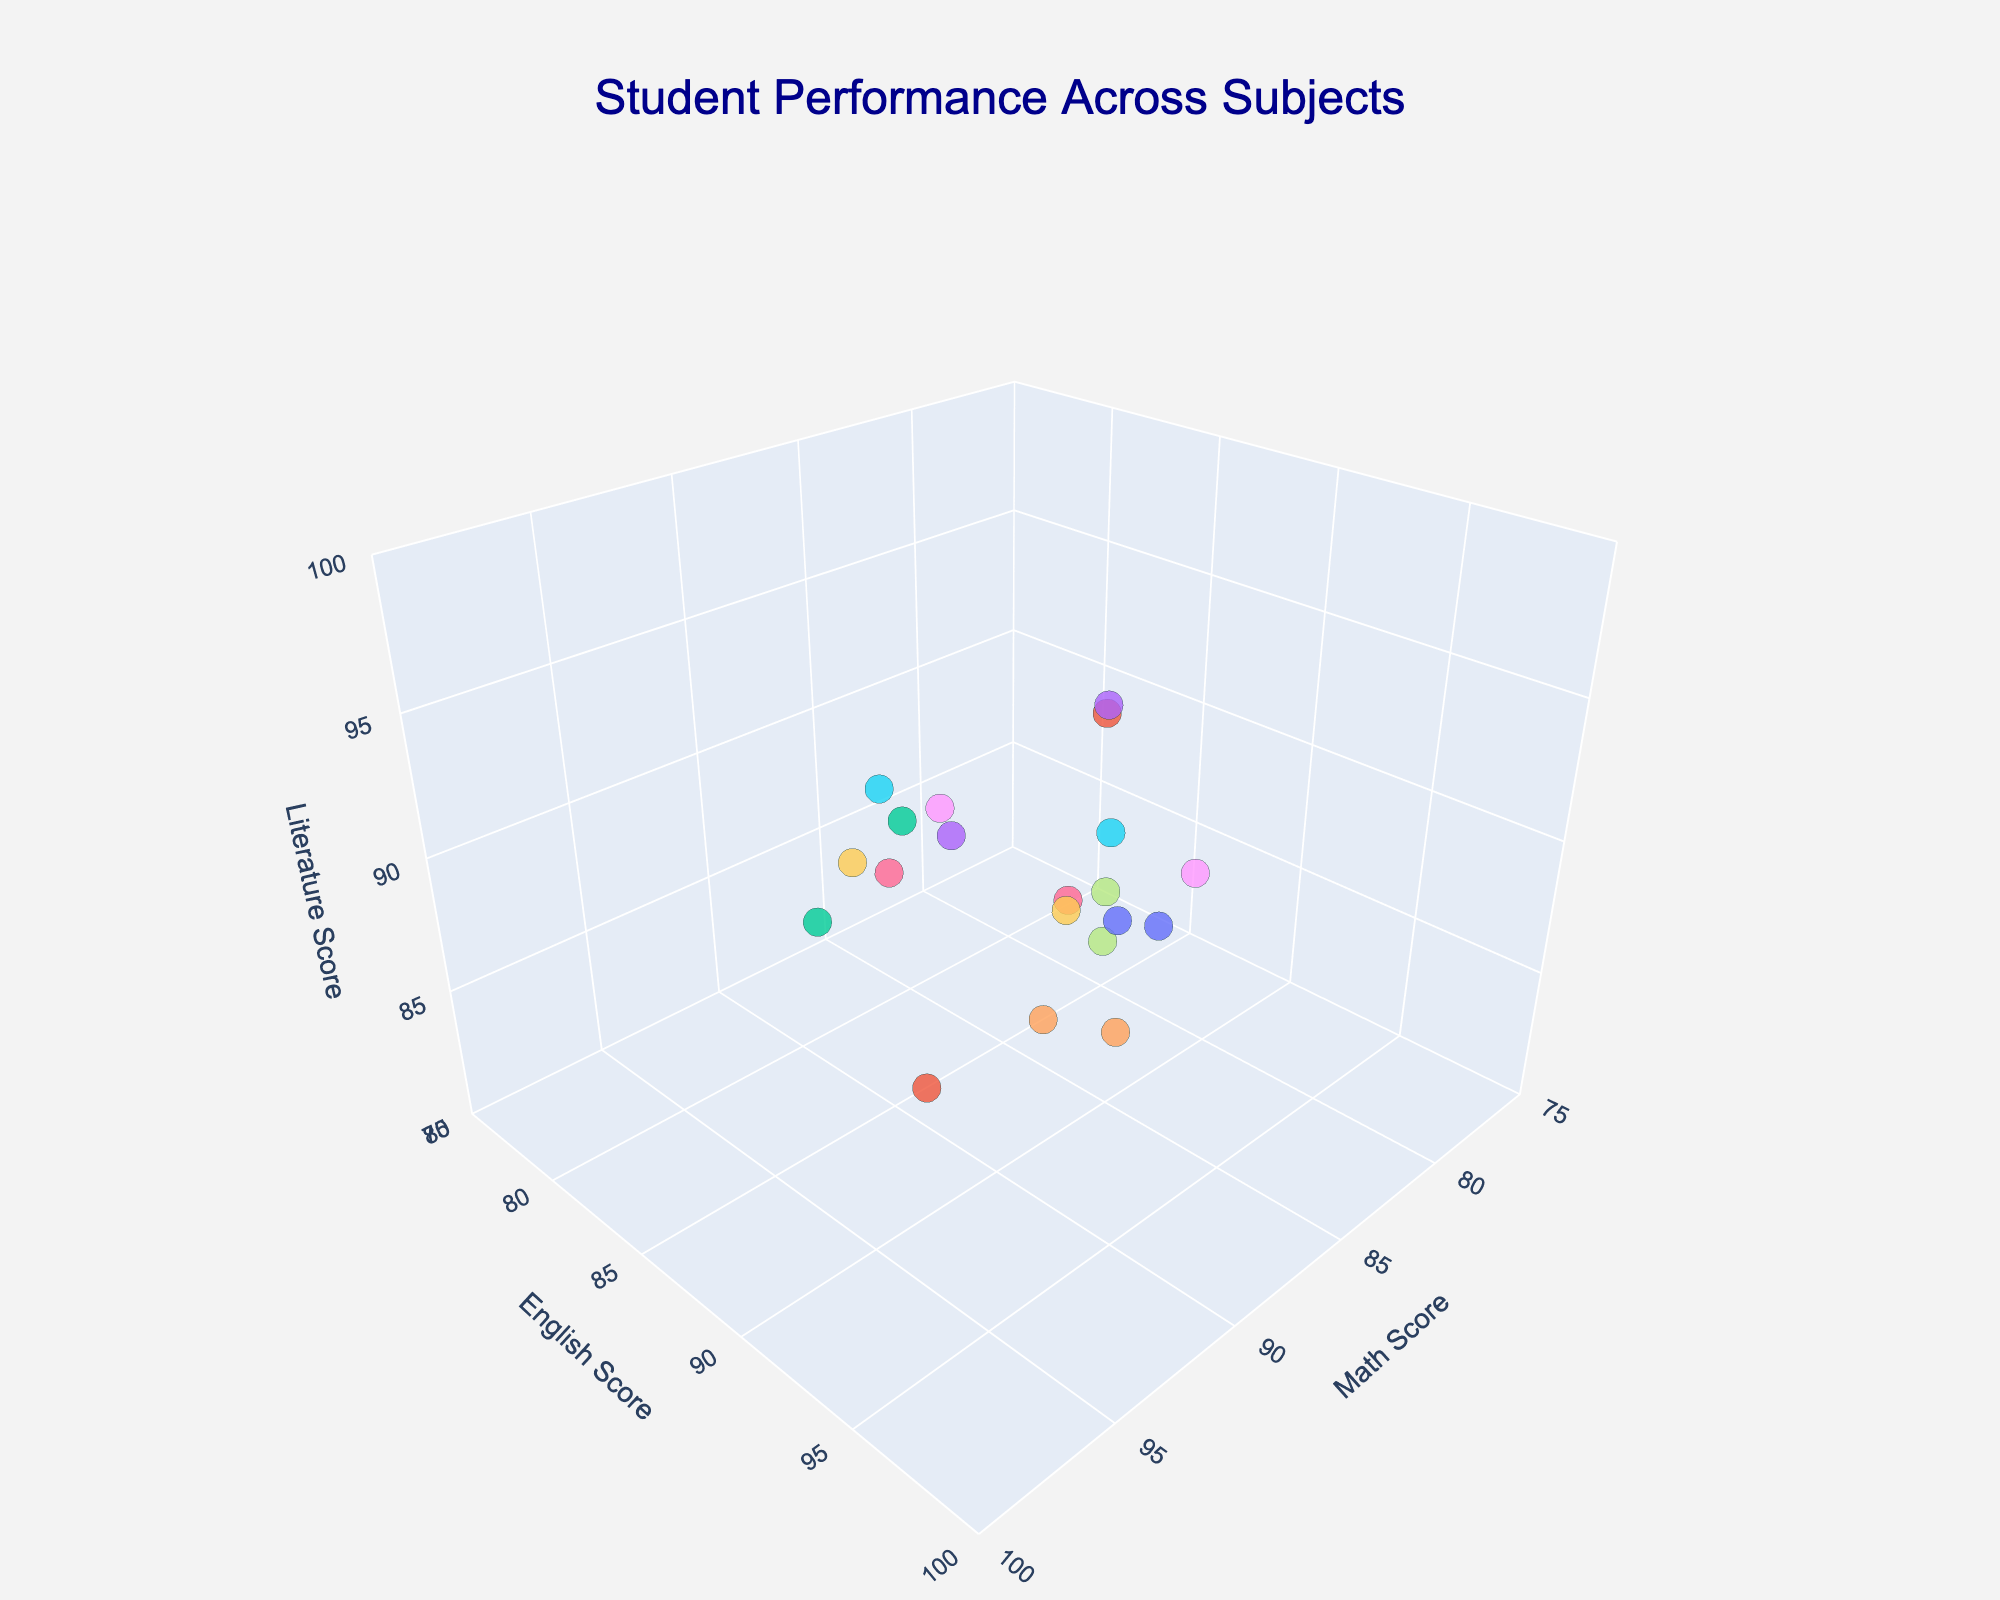What's the title of the plot? The title of the plot is prominently displayed at the top of the figure in larger font size and dark blue color. It helps the viewer understand the overall focus of the visual.
Answer: Student Performance Across Subjects What are the ranges for the axes? By looking at the axis labels and tick marks, one can observe that the ranges for the Math and English axes are from 75 to 100, and for the Literature axis, it is from 80 to 100.
Answer: Math: 75-100, English: 75-100, Literature: 80-100 Who scored highest in Literature, and what was the score? By observing the highest point on the Literature axis, and identifying the associated student from the hover information, it's clear that Isabella Ahmed scored the highest.
Answer: Isabella Ahmed, 95 Which student has the highest combined score across all three subjects? To find the answer, add up the scores for each subject for all students. Among the sums, Isabella Ahmed has the highest combined score: 93 (Math) + 91 (English) + 95 (Literature) = 279.
Answer: Isabella Ahmed What is the average English score of all students displayed? Add all the English scores and divide by the total number of students. The English scores sum to 1648 and there are 20 students: 1648 / 20 = 82.4.
Answer: 82.4 Which two students have the most similar scores in Math? Identify the students who are closest together along the Math axis by viewing the data points and hover information. Emma Thompson and Zoe Brown both score between 85 and 86, showing great similarity.
Answer: Emma Thompson and Zoe Brown How does Olivia Rodriguez's Literature score compare to Noah Kim's? Locate Olivia and Noah's points using the hover information. Olivia scored 87 in Literature, whereas Noah scored 93. Therefore, Noah's score is higher.
Answer: Noah's is higher What is the Math score of the student with the second-highest English score? First, identify the student with the highest English score, Lily White. Then, recognize Olivia Rodriguez as the student with the second-highest score of 94 in English. Her Math score is 89.
Answer: 89 Which student shows consistent high performance (scoring above 85) in all three subjects? Looking at the plot, and based on the hover data, students scoring above 85 in all subjects are Noah Kim, Isabella Ahmed, and Chloe Martinez; Noah Kim has the best scores at 91, 86, and 93 respectively.
Answer: Noah Kim 